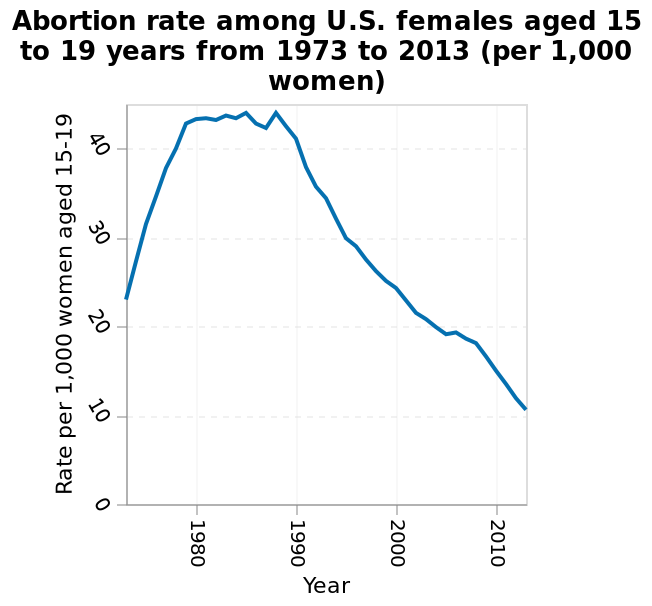<image>
What has happened to the abortion trends for US females aged 15 to 19 from 1990 onwards? From 1990 onwards, the abortion trends for US females aged 15 to 19 have consistently fallen. What is the range of values for the y-axis? The range of values for the y-axis is from 0 to 40. What age group does the line diagram focus on? The line diagram focuses on females aged 15 to 19 years. 